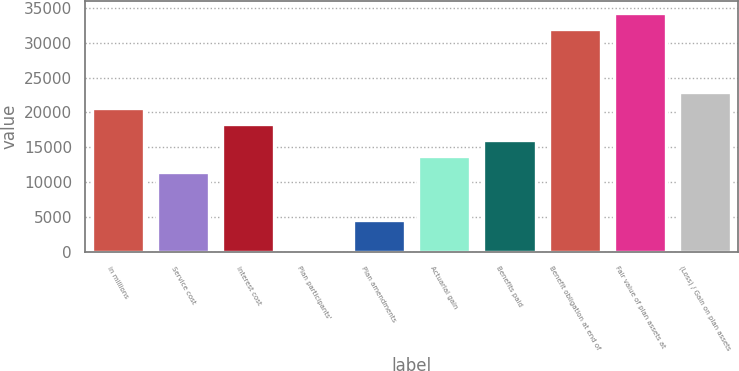Convert chart to OTSL. <chart><loc_0><loc_0><loc_500><loc_500><bar_chart><fcel>in millions<fcel>Service cost<fcel>Interest cost<fcel>Plan participants'<fcel>Plan amendments<fcel>Actuarial gain<fcel>Benefits paid<fcel>Benefit obligation at end of<fcel>Fair value of plan assets at<fcel>(Loss) / Gain on plan assets<nl><fcel>20603.3<fcel>11452.5<fcel>18315.6<fcel>14<fcel>4589.4<fcel>13740.2<fcel>16027.9<fcel>32041.8<fcel>34329.5<fcel>22891<nl></chart> 